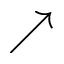<formula> <loc_0><loc_0><loc_500><loc_500>\nearrow</formula> 